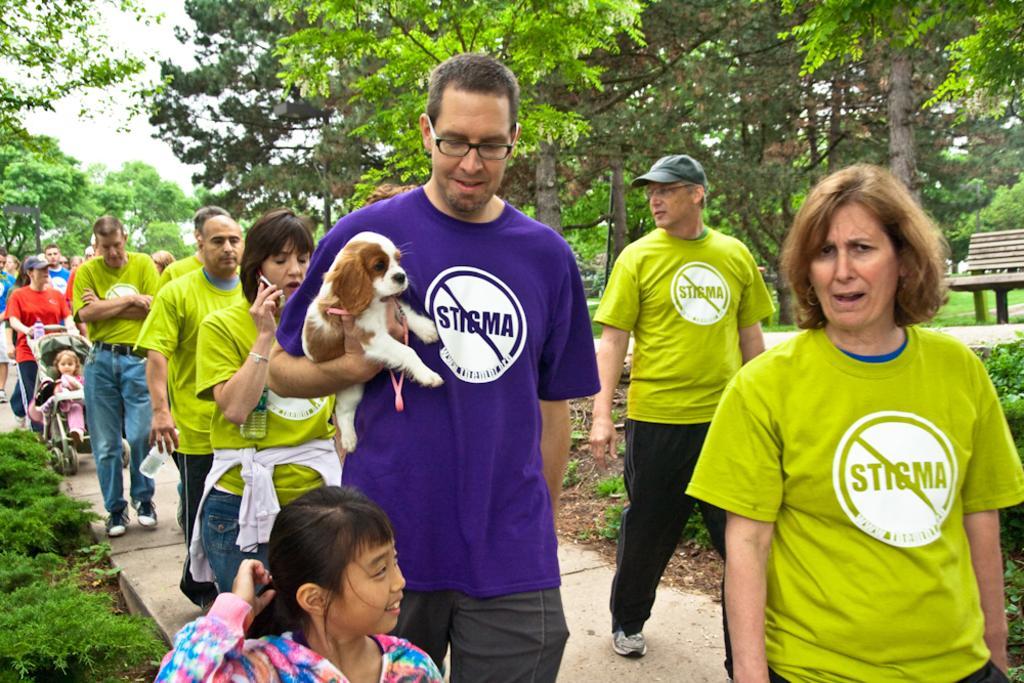Describe this image in one or two sentences. Here we can see a group of people walking and the man in the front is having a dog in his hand and behind them we can see trees and plants and at the middle of the right side we can see a bench 